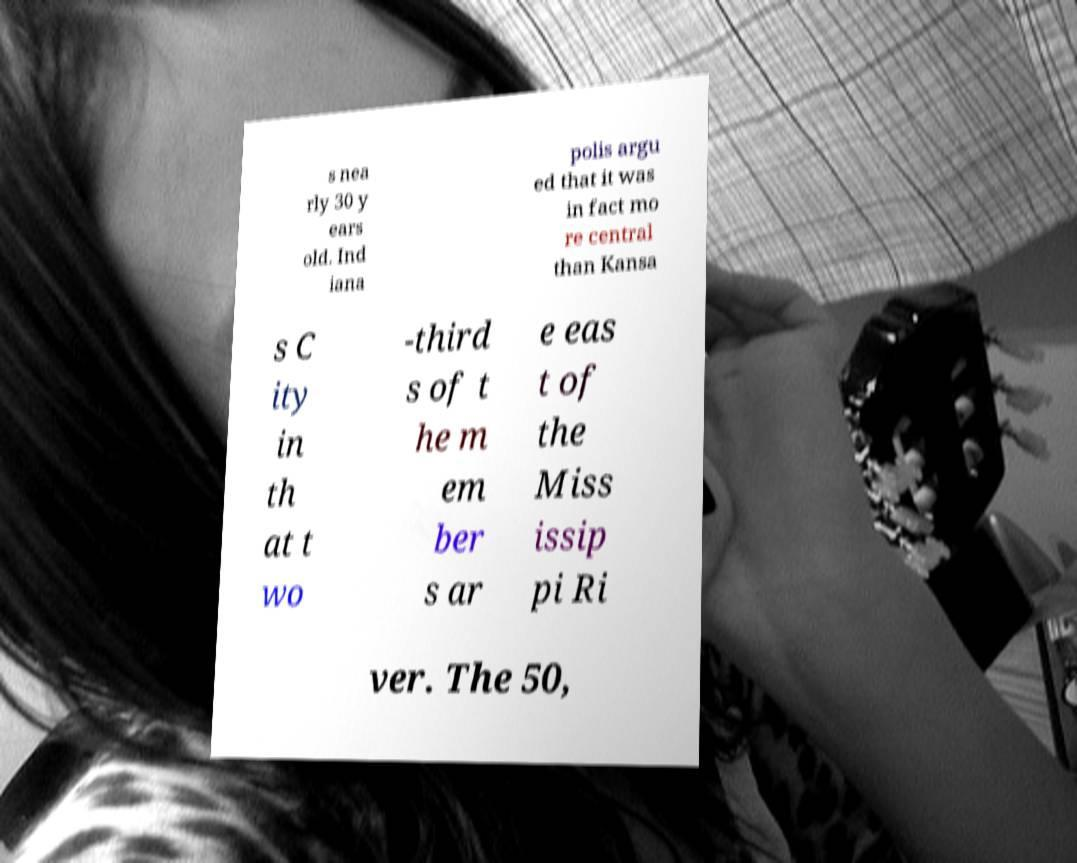What messages or text are displayed in this image? I need them in a readable, typed format. s nea rly 30 y ears old. Ind iana polis argu ed that it was in fact mo re central than Kansa s C ity in th at t wo -third s of t he m em ber s ar e eas t of the Miss issip pi Ri ver. The 50, 